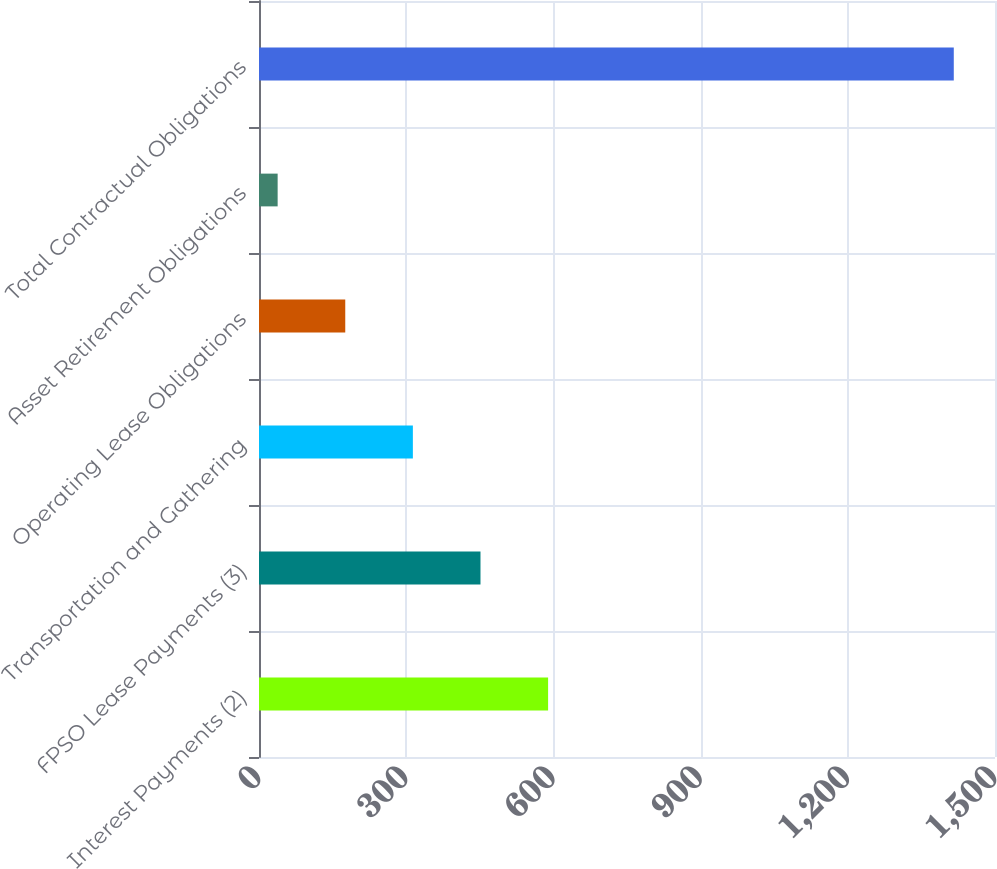Convert chart. <chart><loc_0><loc_0><loc_500><loc_500><bar_chart><fcel>Interest Payments (2)<fcel>FPSO Lease Payments (3)<fcel>Transportation and Gathering<fcel>Operating Lease Obligations<fcel>Asset Retirement Obligations<fcel>Total Contractual Obligations<nl><fcel>589.2<fcel>451.4<fcel>313.6<fcel>175.8<fcel>38<fcel>1416<nl></chart> 